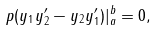<formula> <loc_0><loc_0><loc_500><loc_500>p ( y _ { 1 } y ^ { \prime } _ { 2 } - y _ { 2 } y ^ { \prime } _ { 1 } ) | _ { a } ^ { b } = 0 ,</formula> 